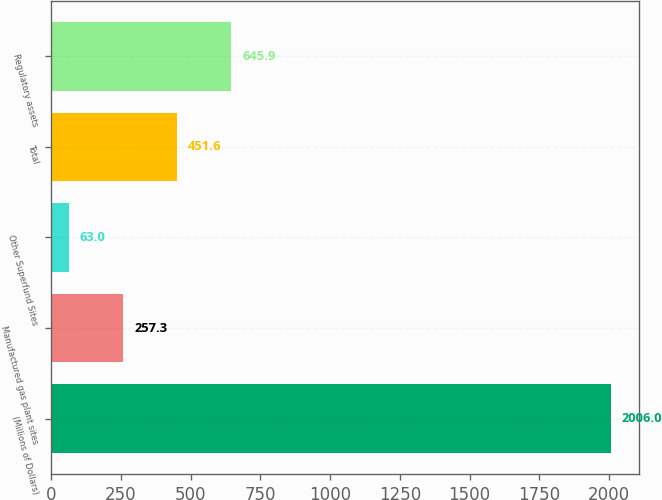Convert chart to OTSL. <chart><loc_0><loc_0><loc_500><loc_500><bar_chart><fcel>(Millions of Dollars)<fcel>Manufactured gas plant sites<fcel>Other Superfund Sites<fcel>Total<fcel>Regulatory assets<nl><fcel>2006<fcel>257.3<fcel>63<fcel>451.6<fcel>645.9<nl></chart> 